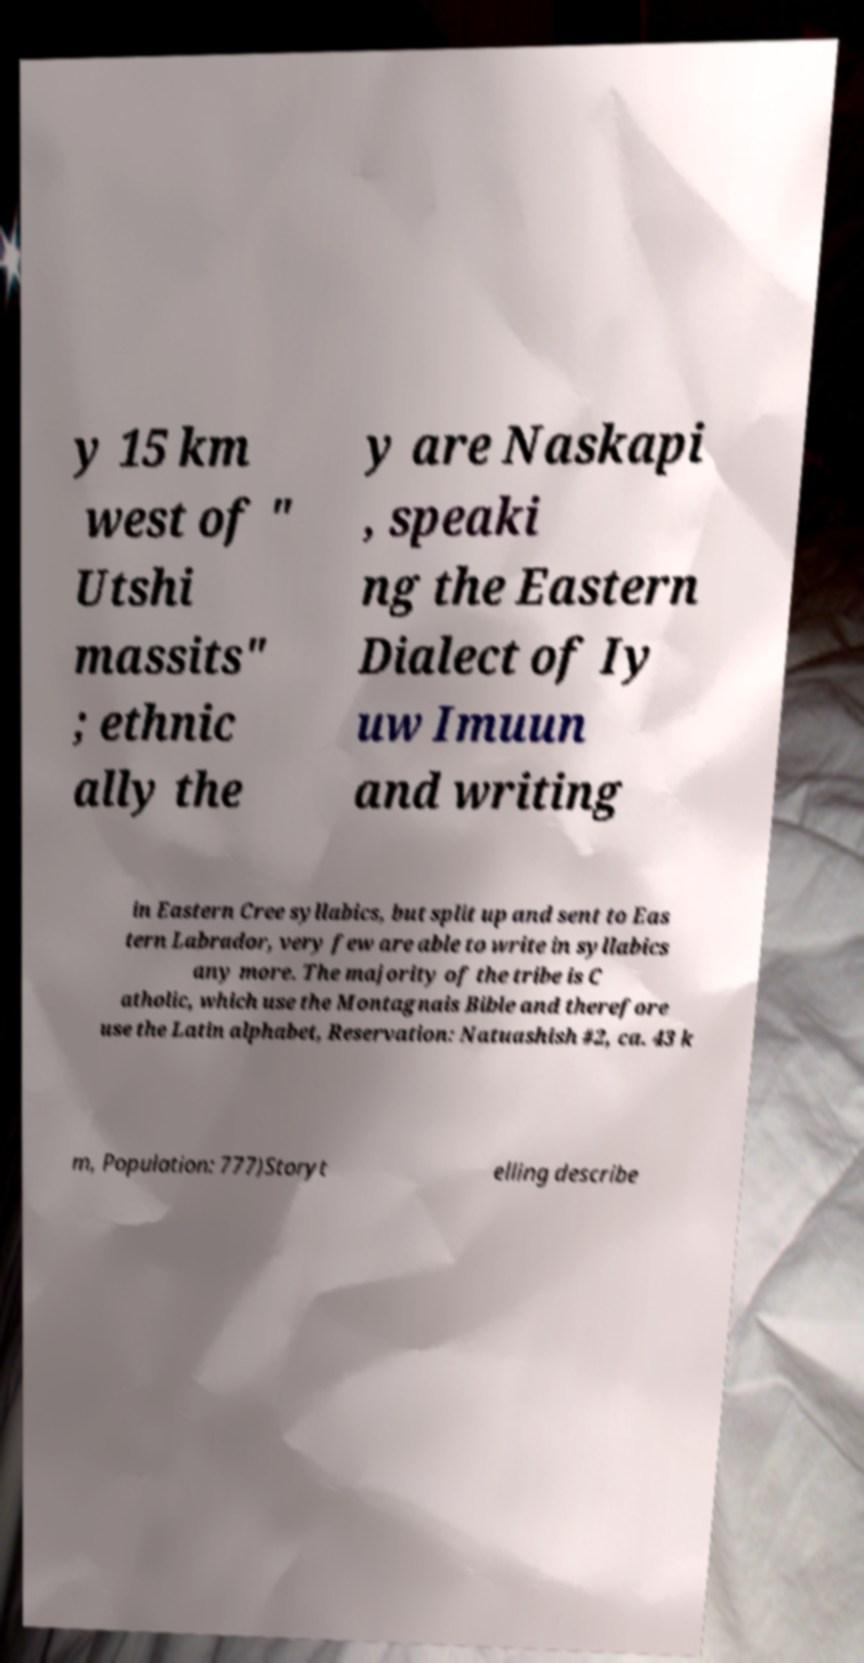I need the written content from this picture converted into text. Can you do that? y 15 km west of " Utshi massits" ; ethnic ally the y are Naskapi , speaki ng the Eastern Dialect of Iy uw Imuun and writing in Eastern Cree syllabics, but split up and sent to Eas tern Labrador, very few are able to write in syllabics any more. The majority of the tribe is C atholic, which use the Montagnais Bible and therefore use the Latin alphabet, Reservation: Natuashish #2, ca. 43 k m, Population: 777)Storyt elling describe 